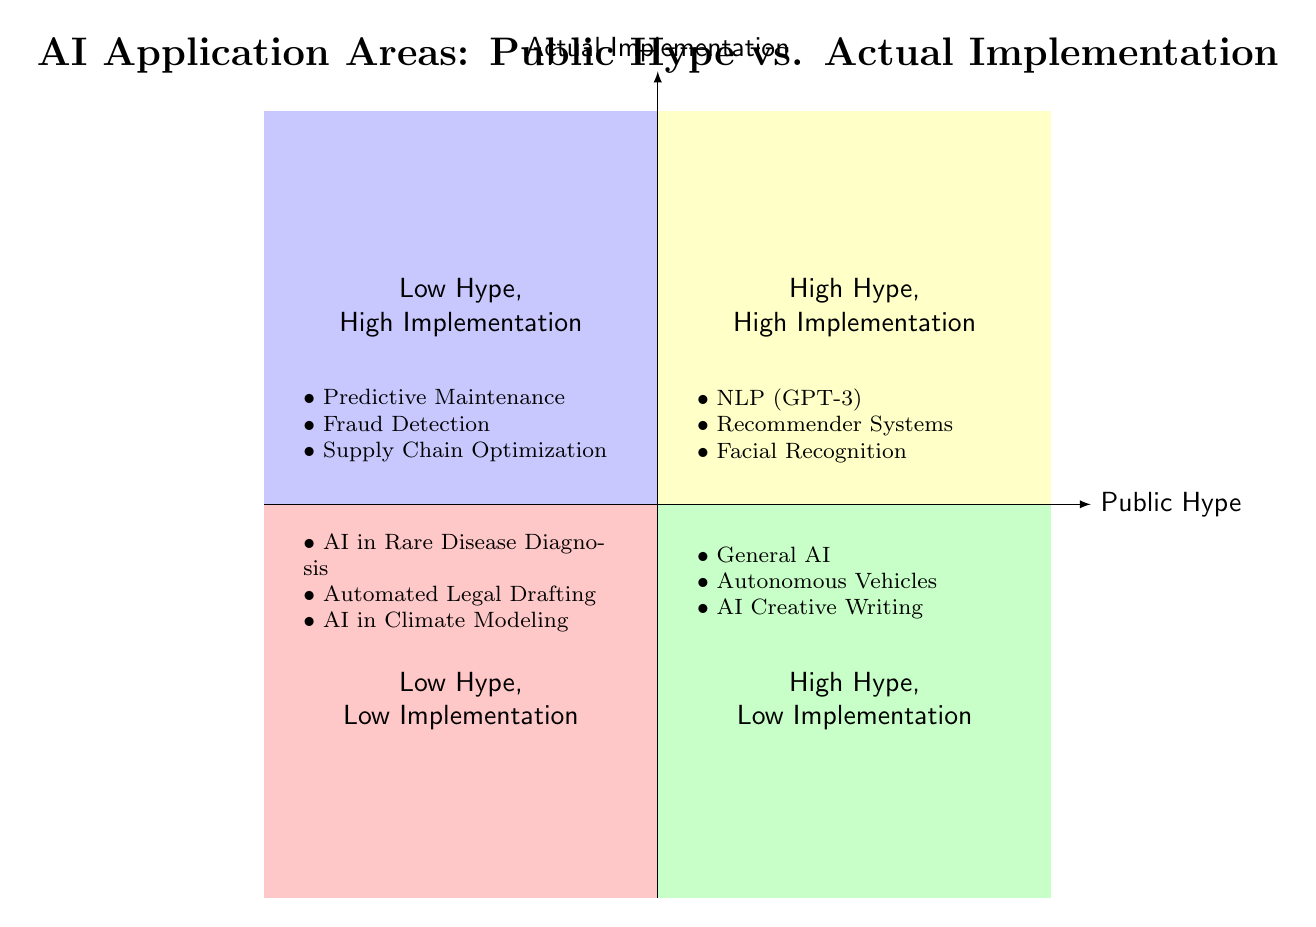What area does "Natural Language Processing" fall into? "Natural Language Processing" is listed under the "High Hype, High Implementation" quadrant, which is indicated by its position at the intersection of high public hype and high actual implementation on the chart.
Answer: High Hype, High Implementation How many examples are in the "Low Hype, Low Implementation" quadrant? The "Low Hype, Low Implementation" quadrant contains three examples: AI in Rare Disease Diagnosis, Automated Legal Document Drafting, and AI in Climate Modeling. Therefore, the count of examples in this quadrant is three.
Answer: 3 Which quadrant contains "Fully Autonomous Vehicles"? "Fully Autonomous Vehicles" is mentioned in the "High Hype, Low Implementation" quadrant, showing that while there is significant public interest and hype, actual implementation is lacking.
Answer: High Hype, Low Implementation Name a domain with high implementation but low hype. The "Low Hype, High Implementation" quadrant lists Predictive Maintenance in Manufacturing, Fraud Detection Systems, and Supply Chain Optimization, illustrating areas where AI is effectively integrated with minimal public hype.
Answer: Predictive Maintenance in Manufacturing What is the relationship between hype and implementation in the "High Hype, High Implementation" quadrant? In the "High Hype, High Implementation" quadrant, there is a positive relationship, where applications like Natural Language Processing have garnered both significant public interest and have been effectively implemented in real-world scenarios.
Answer: Positive relationship Name one application area that is in both high hype and low implementation. "AI-Driven Creative Writing" is an example that appears under the "High Hype, Low Implementation" quadrant, indicating that while there is considerable excitement around this area, it has not yet been effectively implemented.
Answer: AI-Driven Creative Writing What color represents the "Low Hype, High Implementation" quadrant? The "Low Hype, High Implementation" quadrant is represented in a light blue color, which differentiates it visually from the other quadrants in the chart for easy identification.
Answer: Light Blue Which quadrant has applications related to manufacturing? The "Low Hype, High Implementation" quadrant includes applications like Predictive Maintenance in Manufacturing, highlighting that this area has effective implementation with less public attention.
Answer: Low Hype, High Implementation 